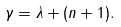Convert formula to latex. <formula><loc_0><loc_0><loc_500><loc_500>\gamma = \lambda + ( n + 1 ) .</formula> 